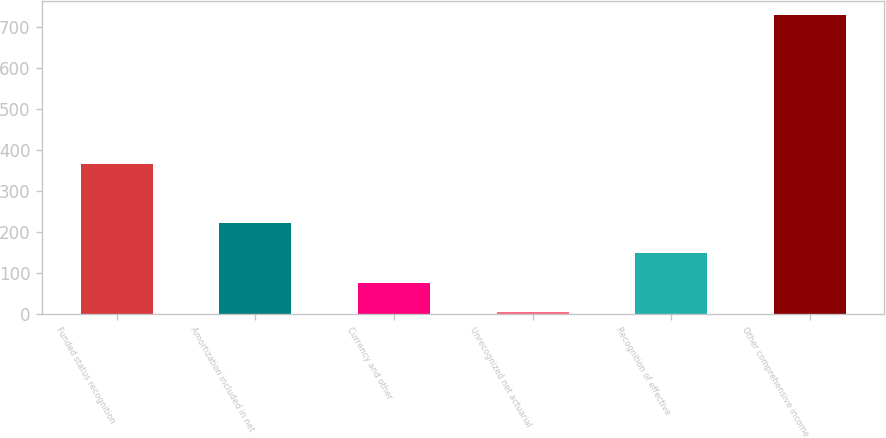<chart> <loc_0><loc_0><loc_500><loc_500><bar_chart><fcel>Funded status recognition<fcel>Amortization included in net<fcel>Currency and other<fcel>Unrecognized net actuarial<fcel>Recognition of effective<fcel>Other comprehensive income<nl><fcel>366.65<fcel>221.75<fcel>76.85<fcel>4.4<fcel>149.3<fcel>728.9<nl></chart> 